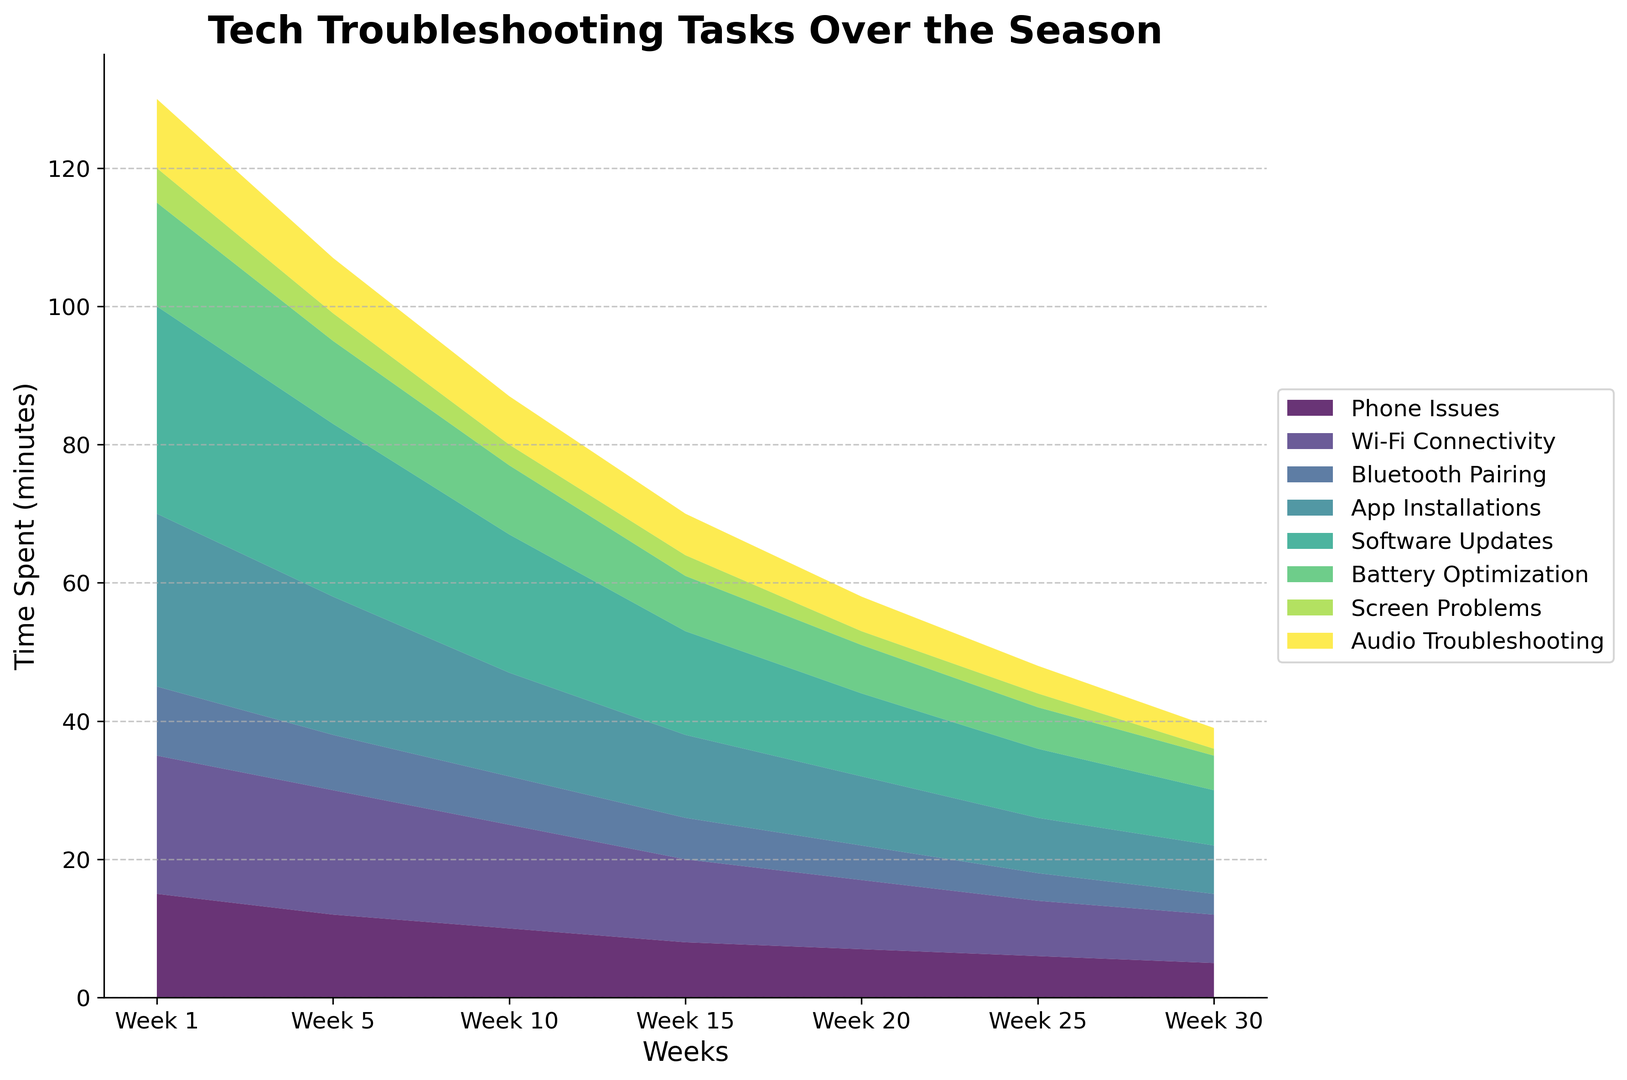What task consistently requires the most troubleshooting time throughout the season? By observing the heights in the area chart, the task with the most accumulated height over the weeks is 'Software Updates'.
Answer: Software Updates Which tasks show a decrease in time spent on them as the season progresses? By looking at the slope of the areas, 'Phone Issues,' 'Wi-Fi Connectivity,' 'Bluetooth Pairing,' 'App Installations,' 'Software Updates,' 'Battery Optimization,' 'Screen Problems,' and 'Audio Troubleshooting' all show a decrease over the weeks.
Answer: All tasks Between 'Wi-Fi Connectivity' and 'App Installations,' which task dropped more significantly from Week 1 to Week 30? Subtract the value of Week 30 from Week 1 for both tasks: Wi-Fi Connectivity (20-7=13) and App Installations (25-7=18). 'App Installations' shows a larger drop.
Answer: App Installations What is the average time spent on 'Battery Optimization' over the entire season? Sum the times for 'Battery Optimization' and divide by the number of weeks: (15 + 12 + 10 + 8 + 7 + 6 + 5)/7 = 63/7 = 9
Answer: 9 How much total time was spent on 'Software Updates' during Weeks 5 and 10? Add the values of 'Software Updates' for Week 5 and Week 10: 25 + 20 = 45
Answer: 45 Which task starts with the smallest amount of troubleshooting time at Week 1 and how much is it? By looking at the heights of areas in Week 1, 'Screen Problems' starts with the smallest time at 5 minutes.
Answer: Screen Problems, 5 minutes Is there any week where more time was spent on 'App Installations' than 'Software Updates'? Compare the height of the areas of 'App Installations' and 'Software Updates' week by week; 'Software Updates' always maintains a larger area.
Answer: No From Week 1 to Week 30, which task reduced its troubleshooting time the fastest? By comparing the slopes, 'Screen Problems' shows the steepest slope downwards, indicating the fastest reduction.
Answer: Screen Problems In Week 10, what tasks consumed more time than 'Bluetooth Pairing'? According to the chart for Week 10, 'Phone Issues,' 'Wi-Fi Connectivity,' 'App Installations,' 'Software Updates,' and 'Battery Optimization' all have taller areas than 'Bluetooth Pairing'.
Answer: Phone Issues, Wi-Fi Connectivity, App Installations, Software Updates, Battery Optimization 